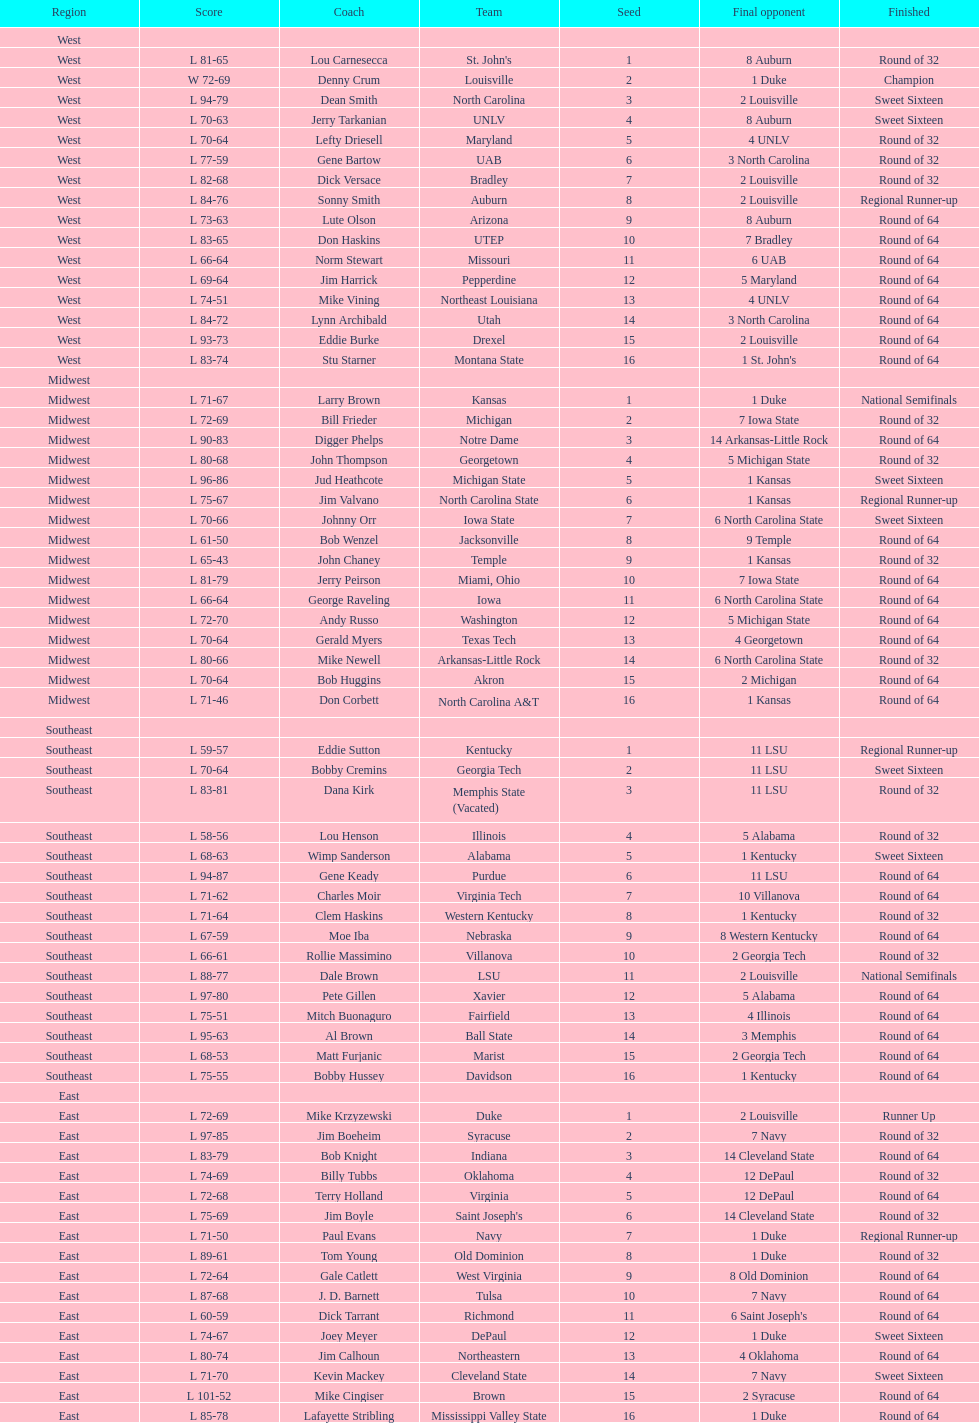Who is the only team from the east region to reach the final round? Duke. 